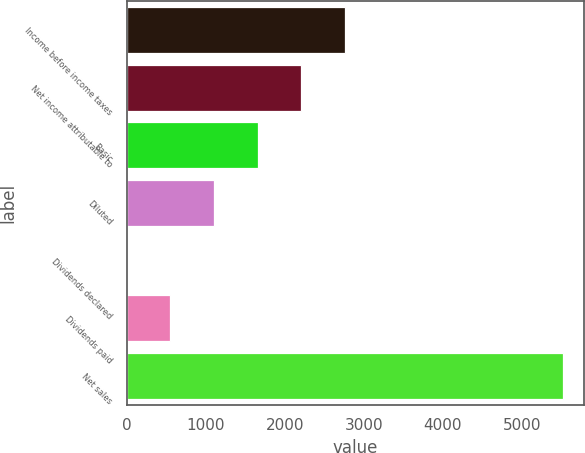Convert chart to OTSL. <chart><loc_0><loc_0><loc_500><loc_500><bar_chart><fcel>Income before income taxes<fcel>Net income attributable to<fcel>Basic<fcel>Diluted<fcel>Dividends declared<fcel>Dividends paid<fcel>Net sales<nl><fcel>2757.21<fcel>2205.85<fcel>1654.49<fcel>1103.13<fcel>0.41<fcel>551.77<fcel>5514<nl></chart> 